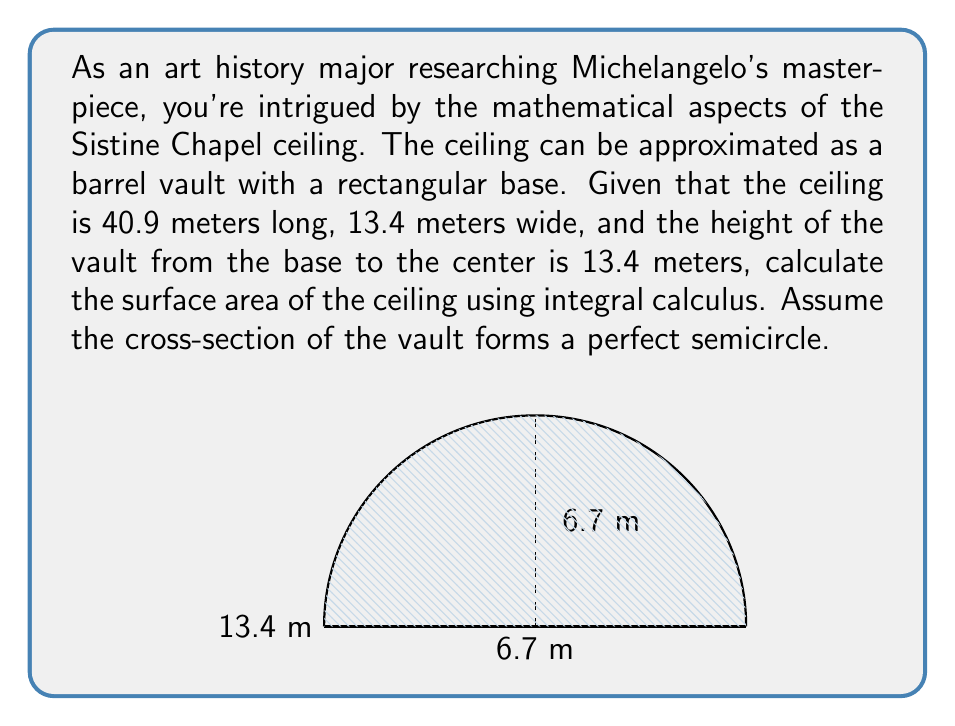Help me with this question. To solve this problem, we'll use the arc length formula from integral calculus. Let's approach this step-by-step:

1) First, we need to set up our coordinate system. Let's place the origin at the bottom left corner of the cross-section, with x going across and y going up.

2) The equation of a circle with radius r and center (r,0) is:
   $$(x-r)^2 + y^2 = r^2$$

3) In our case, r = 6.7 meters (half the width). So our equation is:
   $$(x-6.7)^2 + y^2 = 6.7^2$$

4) Solving for y:
   $$y = \sqrt{6.7^2 - (x-6.7)^2}$$

5) The arc length formula in calculus is:
   $$L = \int_a^b \sqrt{1 + \left(\frac{dy}{dx}\right)^2} dx$$

6) We need to find $\frac{dy}{dx}$:
   $$\frac{dy}{dx} = \frac{-(x-6.7)}{\sqrt{6.7^2 - (x-6.7)^2}}$$

7) Substituting this into our arc length formula:
   $$L = \int_0^{13.4} \sqrt{1 + \frac{(x-6.7)^2}{6.7^2 - (x-6.7)^2}} dx$$

8) This integral doesn't have an elementary antiderivative, but we know the result: it's the length of a semicircle with radius 6.7 meters, which is $\pi r = \pi(6.7) = 21.0486$ meters.

9) Now, to get the surface area, we need to multiply this by the length of the ceiling:
   $$\text{Surface Area} = 21.0486 \times 40.9 = 860.8877 \text{ square meters}$$

Therefore, the surface area of the Sistine Chapel ceiling is approximately 860.89 square meters.
Answer: 860.89 m² 